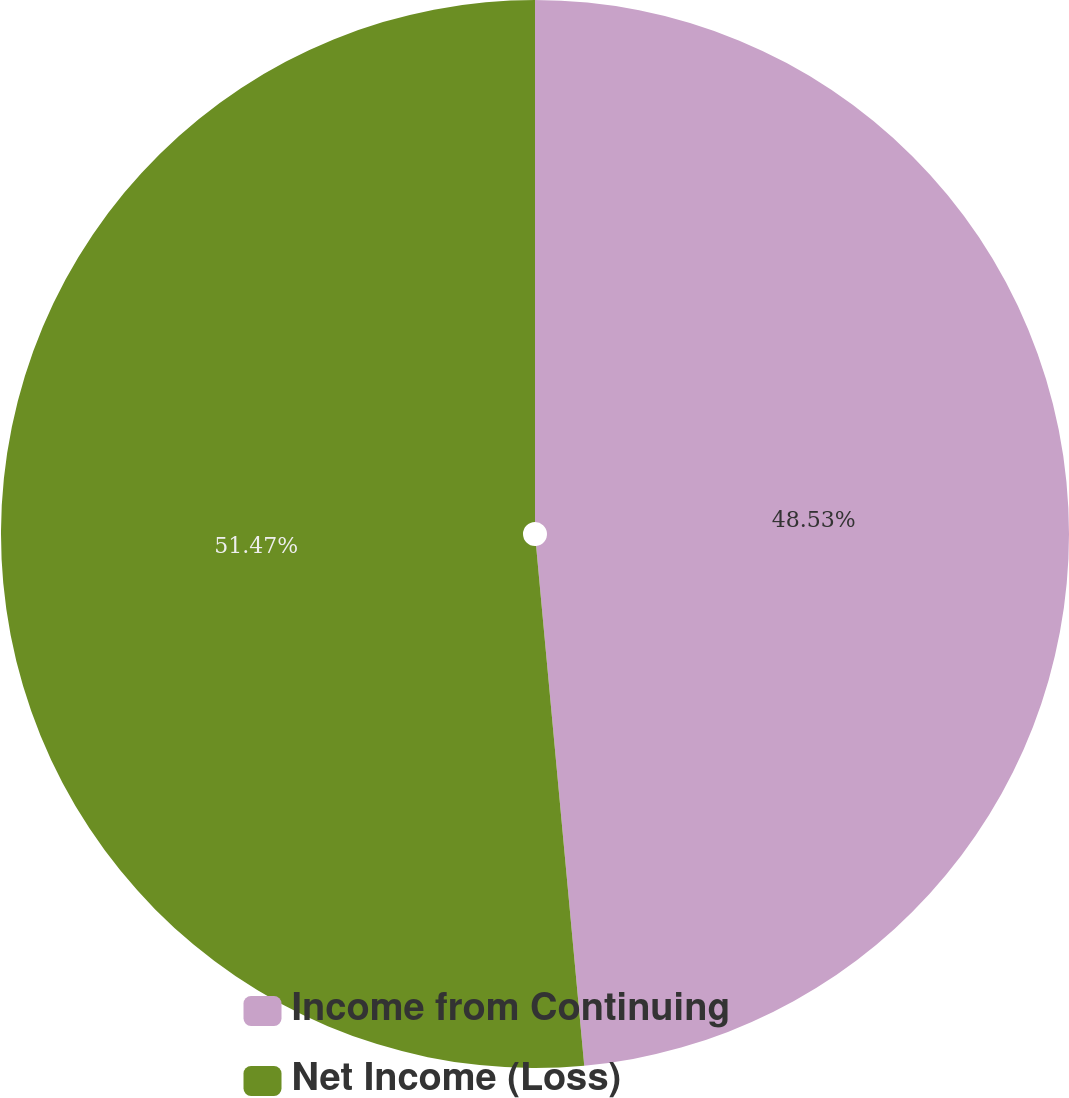Convert chart. <chart><loc_0><loc_0><loc_500><loc_500><pie_chart><fcel>Income from Continuing<fcel>Net Income (Loss)<nl><fcel>48.53%<fcel>51.47%<nl></chart> 